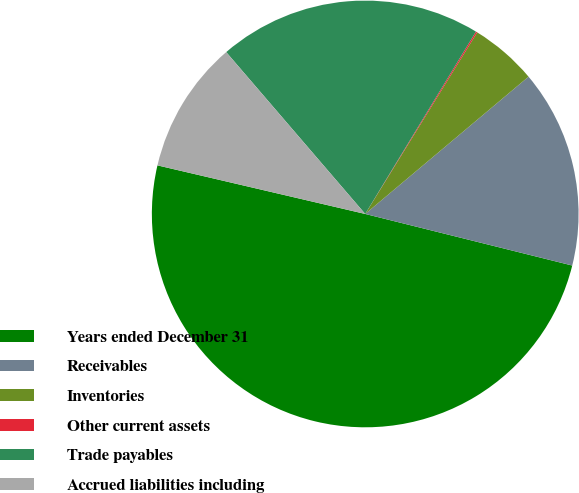Convert chart. <chart><loc_0><loc_0><loc_500><loc_500><pie_chart><fcel>Years ended December 31<fcel>Receivables<fcel>Inventories<fcel>Other current assets<fcel>Trade payables<fcel>Accrued liabilities including<nl><fcel>49.77%<fcel>15.01%<fcel>5.08%<fcel>0.11%<fcel>19.98%<fcel>10.05%<nl></chart> 